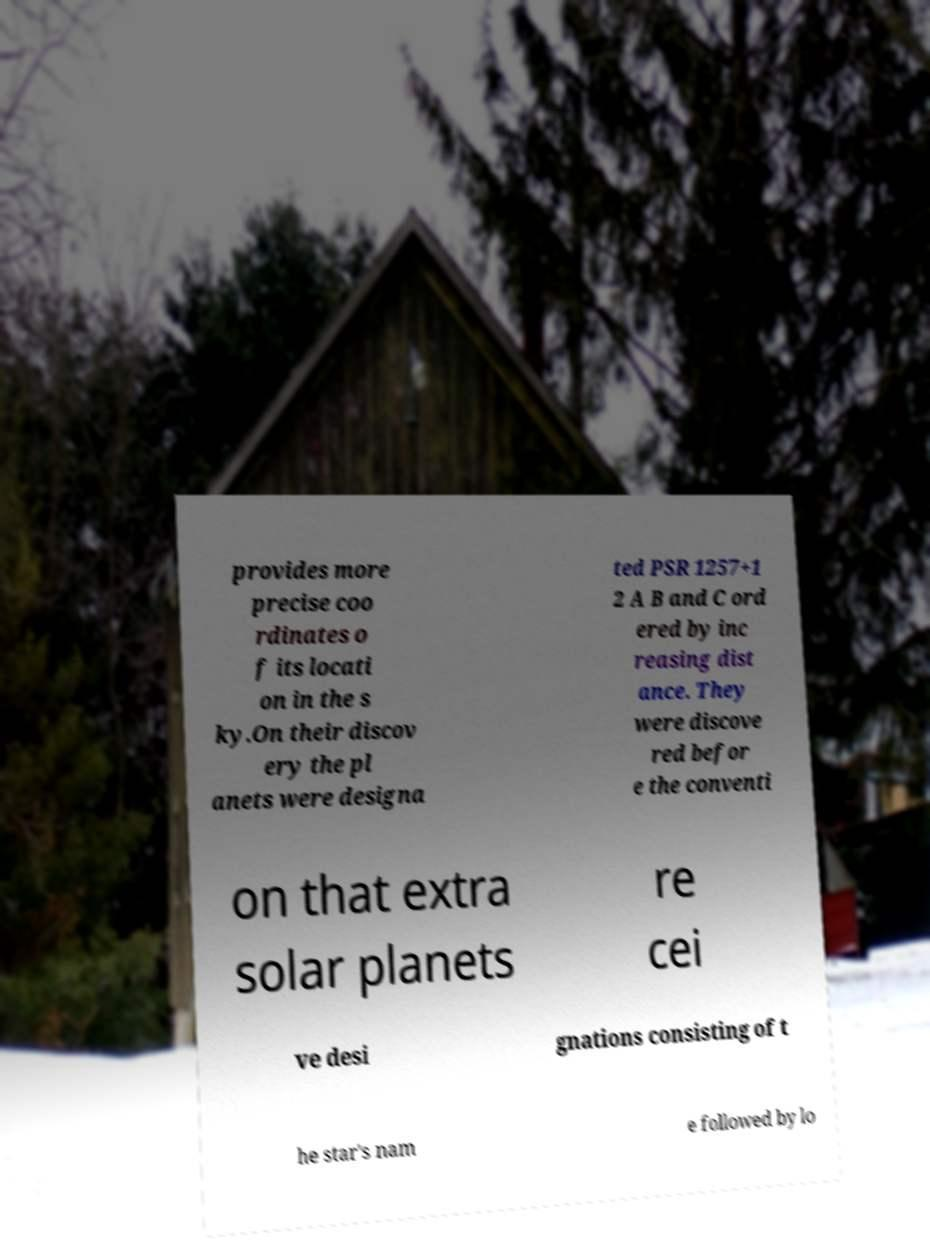Can you read and provide the text displayed in the image?This photo seems to have some interesting text. Can you extract and type it out for me? provides more precise coo rdinates o f its locati on in the s ky.On their discov ery the pl anets were designa ted PSR 1257+1 2 A B and C ord ered by inc reasing dist ance. They were discove red befor e the conventi on that extra solar planets re cei ve desi gnations consisting of t he star's nam e followed by lo 